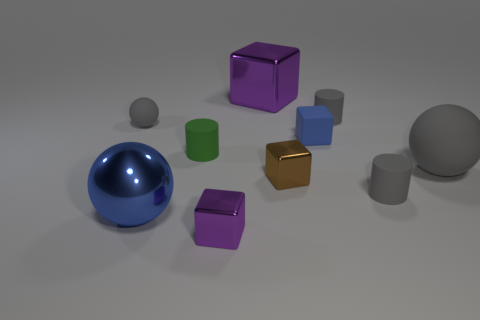There is a tiny block that is the same color as the metal sphere; what is its material?
Your response must be concise. Rubber. Is there a matte object in front of the gray cylinder in front of the big gray rubber ball?
Ensure brevity in your answer.  No. What is the material of the big gray object?
Provide a succinct answer. Rubber. Does the gray cylinder that is in front of the small green thing have the same material as the small green cylinder on the left side of the big gray ball?
Keep it short and to the point. Yes. Are there any other things that have the same color as the shiny ball?
Your answer should be very brief. Yes. What color is the other matte thing that is the same shape as the tiny brown object?
Your answer should be compact. Blue. There is a shiny object that is behind the tiny purple metal thing and to the left of the big purple metallic cube; how big is it?
Your answer should be compact. Large. There is a purple metal object behind the big gray thing; does it have the same shape as the gray matte object that is in front of the tiny brown object?
Offer a very short reply. No. There is a big object that is the same color as the small rubber block; what is its shape?
Give a very brief answer. Sphere. How many blue blocks have the same material as the big purple cube?
Offer a terse response. 0. 